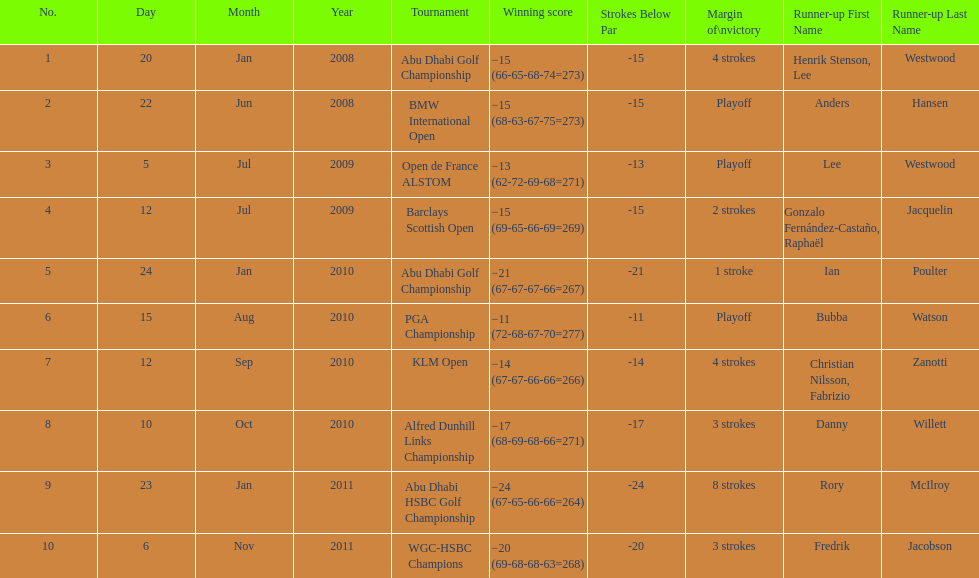Give me the full table as a dictionary. {'header': ['No.', 'Day', 'Month', 'Year', 'Tournament', 'Winning score', 'Strokes Below Par', 'Margin of\\nvictory', 'Runner-up First Name', 'Runner-up Last Name'], 'rows': [['1', '20', 'Jan', '2008', 'Abu Dhabi Golf Championship', '−15 (66-65-68-74=273)', '-15', '4 strokes', 'Henrik Stenson, Lee', 'Westwood'], ['2', '22', 'Jun', '2008', 'BMW International Open', '−15 (68-63-67-75=273)', '-15', 'Playoff', 'Anders', 'Hansen'], ['3', '5', 'Jul', '2009', 'Open de France ALSTOM', '−13 (62-72-69-68=271)', '-13', 'Playoff', 'Lee', 'Westwood'], ['4', '12', 'Jul', '2009', 'Barclays Scottish Open', '−15 (69-65-66-69=269)', '-15', '2 strokes', 'Gonzalo Fernández-Castaño, Raphaël', 'Jacquelin'], ['5', '24', 'Jan', '2010', 'Abu Dhabi Golf Championship', '−21 (67-67-67-66=267)', '-21', '1 stroke', 'Ian', 'Poulter'], ['6', '15', 'Aug', '2010', 'PGA Championship', '−11 (72-68-67-70=277)', '-11', 'Playoff', 'Bubba', 'Watson'], ['7', '12', 'Sep', '2010', 'KLM Open', '−14 (67-67-66-66=266)', '-14', '4 strokes', 'Christian Nilsson, Fabrizio', 'Zanotti'], ['8', '10', 'Oct', '2010', 'Alfred Dunhill Links Championship', '−17 (68-69-68-66=271)', '-17', '3 strokes', 'Danny', 'Willett'], ['9', '23', 'Jan', '2011', 'Abu Dhabi HSBC Golf Championship', '−24 (67-65-66-66=264)', '-24', '8 strokes', 'Rory', 'McIlroy'], ['10', '6', 'Nov', '2011', 'WGC-HSBC Champions', '−20 (69-68-68-63=268)', '-20', '3 strokes', 'Fredrik', 'Jacobson']]} How many more strokes were in the klm open than the barclays scottish open? 2 strokes. 